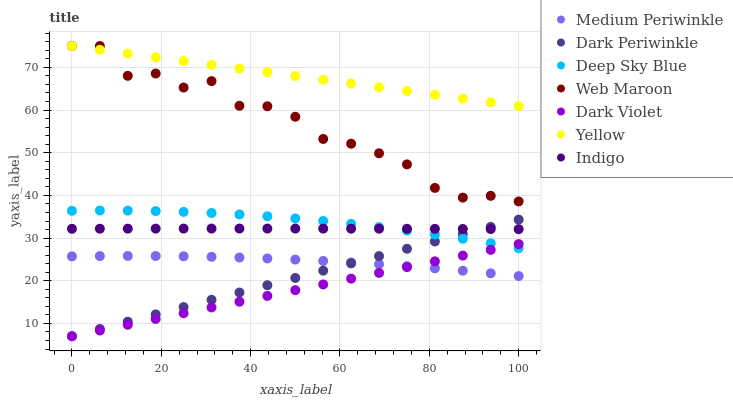Does Dark Violet have the minimum area under the curve?
Answer yes or no. Yes. Does Yellow have the maximum area under the curve?
Answer yes or no. Yes. Does Medium Periwinkle have the minimum area under the curve?
Answer yes or no. No. Does Medium Periwinkle have the maximum area under the curve?
Answer yes or no. No. Is Dark Periwinkle the smoothest?
Answer yes or no. Yes. Is Web Maroon the roughest?
Answer yes or no. Yes. Is Medium Periwinkle the smoothest?
Answer yes or no. No. Is Medium Periwinkle the roughest?
Answer yes or no. No. Does Dark Violet have the lowest value?
Answer yes or no. Yes. Does Medium Periwinkle have the lowest value?
Answer yes or no. No. Does Yellow have the highest value?
Answer yes or no. Yes. Does Medium Periwinkle have the highest value?
Answer yes or no. No. Is Indigo less than Web Maroon?
Answer yes or no. Yes. Is Deep Sky Blue greater than Medium Periwinkle?
Answer yes or no. Yes. Does Indigo intersect Dark Periwinkle?
Answer yes or no. Yes. Is Indigo less than Dark Periwinkle?
Answer yes or no. No. Is Indigo greater than Dark Periwinkle?
Answer yes or no. No. Does Indigo intersect Web Maroon?
Answer yes or no. No. 